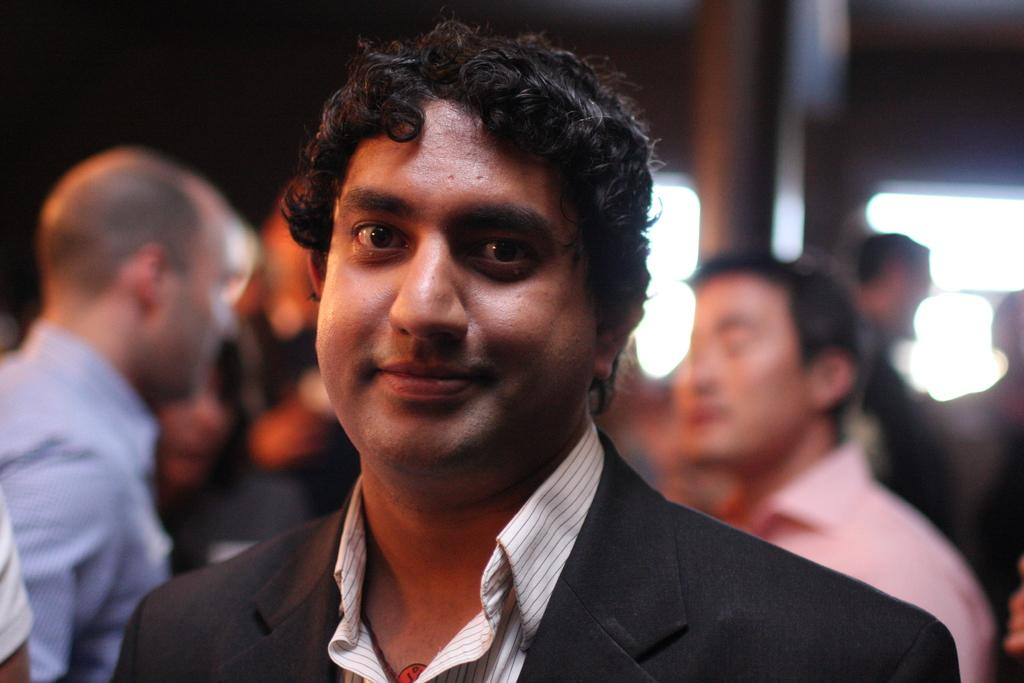What is the main subject of the image? There is a person standing in the image. What is the person wearing in the image? The person is wearing a black color blazer. Can you describe the background of the image? There are other persons standing in the background of the image. What type of bone can be seen in the person's hand in the image? There is no bone visible in the person's hand in the image. What color is the doll that the person is holding in the image? There is no doll present in the image. 